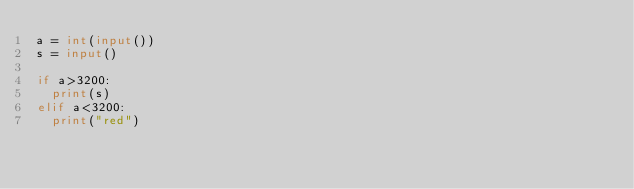<code> <loc_0><loc_0><loc_500><loc_500><_Python_>a = int(input())
s = input()

if a>3200:
  print(s)
elif a<3200:
  print("red")
</code> 